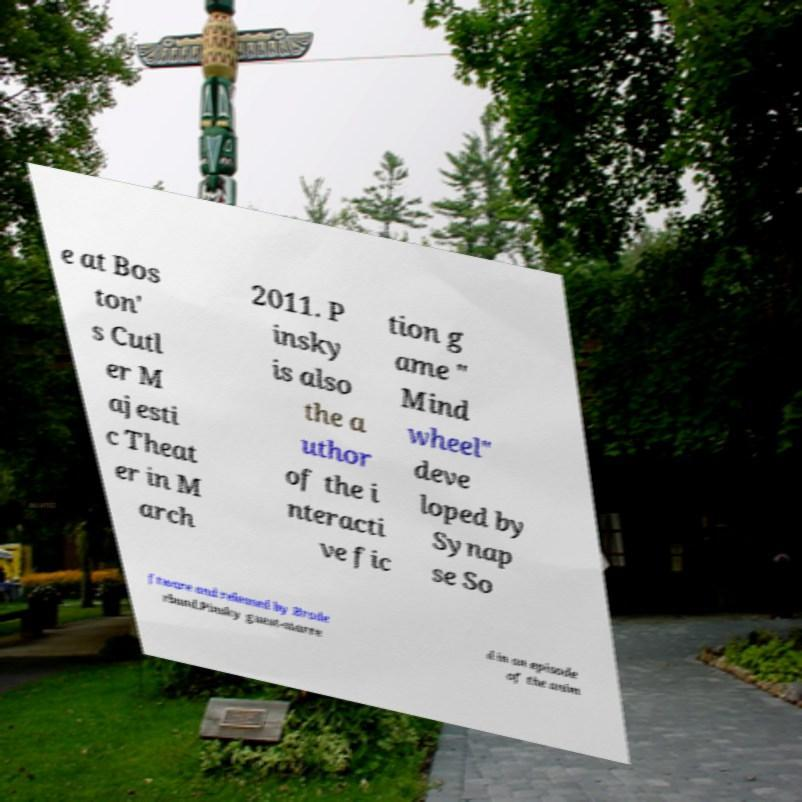For documentation purposes, I need the text within this image transcribed. Could you provide that? e at Bos ton' s Cutl er M ajesti c Theat er in M arch 2011. P insky is also the a uthor of the i nteracti ve fic tion g ame " Mind wheel" deve loped by Synap se So ftware and released by Brode rbund.Pinsky guest-starre d in an episode of the anim 